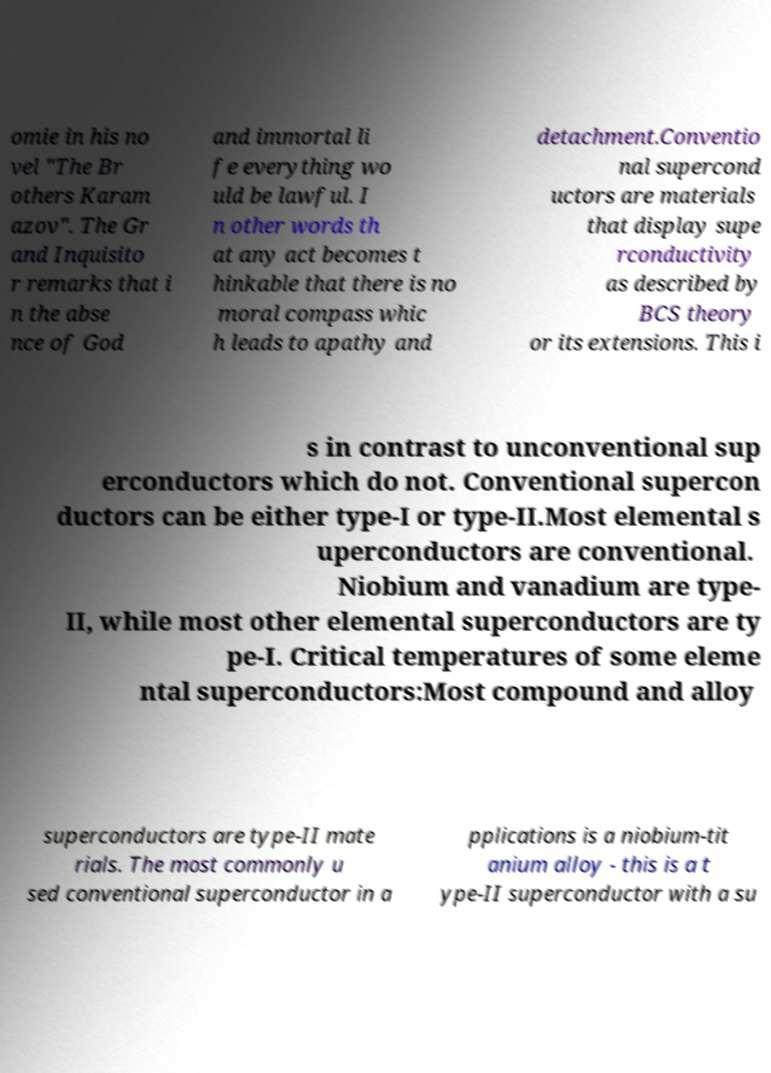There's text embedded in this image that I need extracted. Can you transcribe it verbatim? omie in his no vel "The Br others Karam azov". The Gr and Inquisito r remarks that i n the abse nce of God and immortal li fe everything wo uld be lawful. I n other words th at any act becomes t hinkable that there is no moral compass whic h leads to apathy and detachment.Conventio nal supercond uctors are materials that display supe rconductivity as described by BCS theory or its extensions. This i s in contrast to unconventional sup erconductors which do not. Conventional supercon ductors can be either type-I or type-II.Most elemental s uperconductors are conventional. Niobium and vanadium are type- II, while most other elemental superconductors are ty pe-I. Critical temperatures of some eleme ntal superconductors:Most compound and alloy superconductors are type-II mate rials. The most commonly u sed conventional superconductor in a pplications is a niobium-tit anium alloy - this is a t ype-II superconductor with a su 